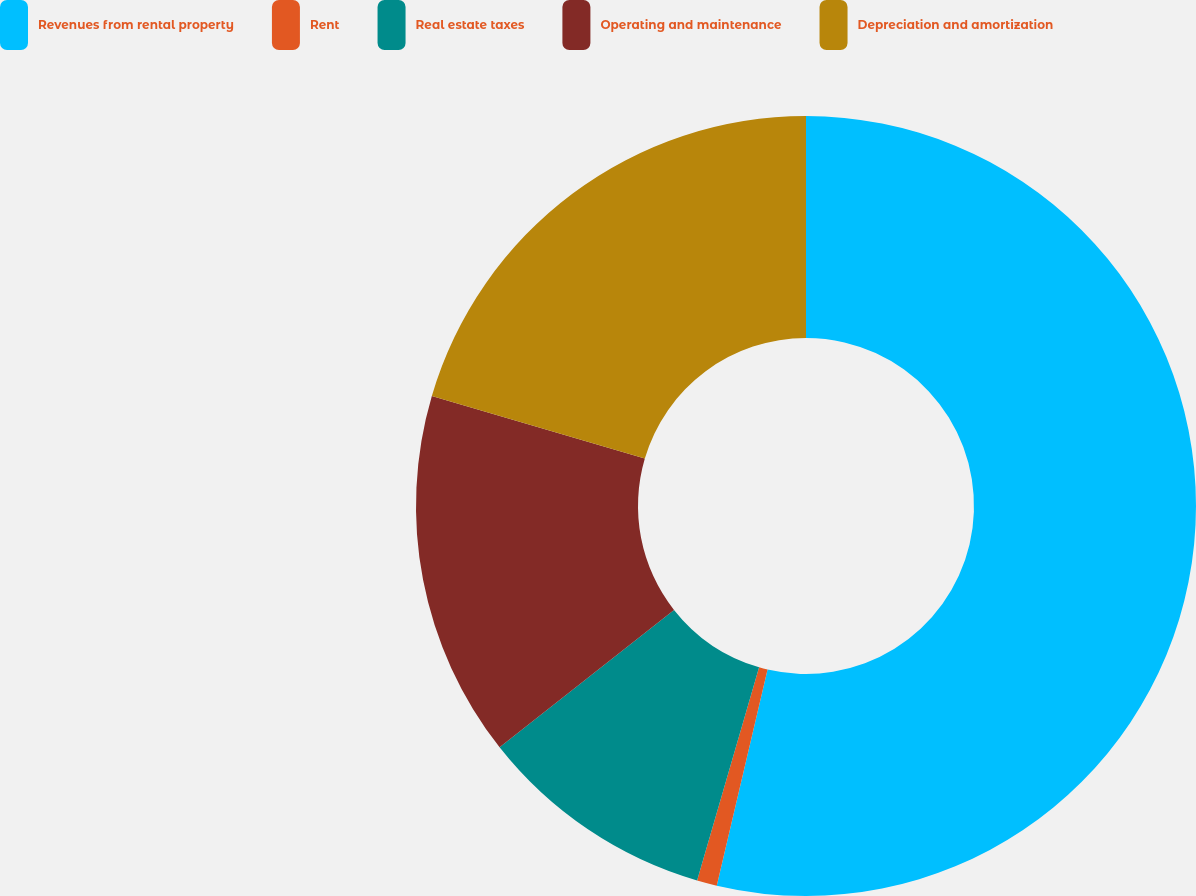Convert chart to OTSL. <chart><loc_0><loc_0><loc_500><loc_500><pie_chart><fcel>Revenues from rental property<fcel>Rent<fcel>Real estate taxes<fcel>Operating and maintenance<fcel>Depreciation and amortization<nl><fcel>53.68%<fcel>0.83%<fcel>9.88%<fcel>15.17%<fcel>20.45%<nl></chart> 